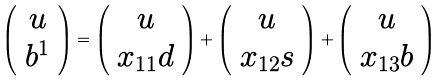<formula> <loc_0><loc_0><loc_500><loc_500>\left ( \begin{array} { c } u \\ b ^ { 1 } \end{array} \right ) = \left ( \begin{array} { c } u \\ x _ { 1 1 } d \end{array} \right ) + \left ( \begin{array} { c } u \\ x _ { 1 2 } s \end{array} \right ) + \left ( \begin{array} { c } u \\ x _ { 1 3 } b \end{array} \right )</formula> 